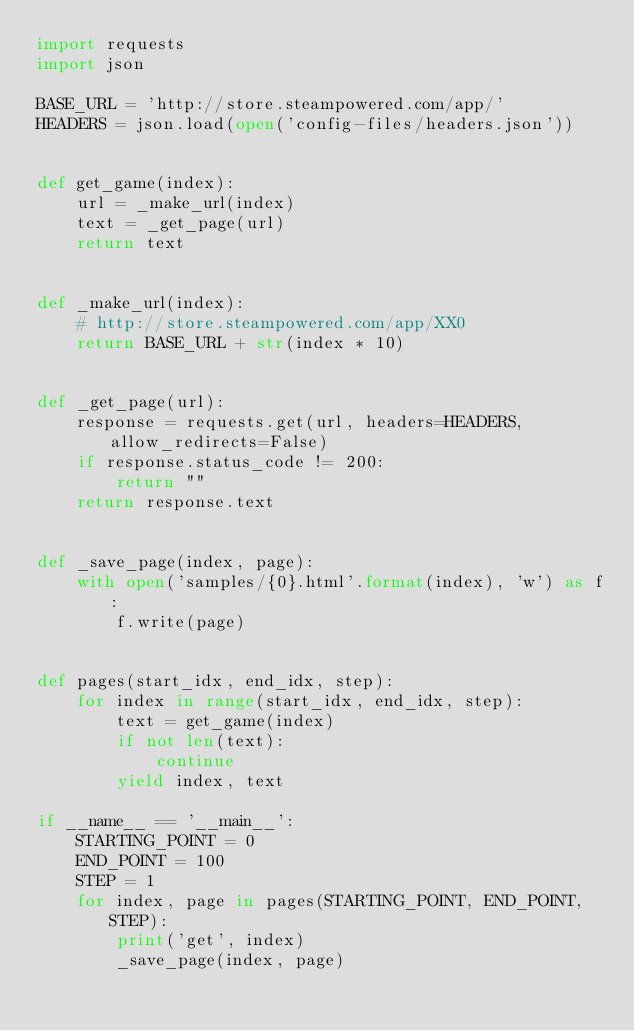Convert code to text. <code><loc_0><loc_0><loc_500><loc_500><_Python_>import requests
import json

BASE_URL = 'http://store.steampowered.com/app/'
HEADERS = json.load(open('config-files/headers.json'))


def get_game(index):
    url = _make_url(index)
    text = _get_page(url)
    return text


def _make_url(index):
    # http://store.steampowered.com/app/XX0
    return BASE_URL + str(index * 10)


def _get_page(url):
    response = requests.get(url, headers=HEADERS, allow_redirects=False)
    if response.status_code != 200:
        return ""
    return response.text


def _save_page(index, page):
    with open('samples/{0}.html'.format(index), 'w') as f:
        f.write(page)


def pages(start_idx, end_idx, step):
    for index in range(start_idx, end_idx, step):
        text = get_game(index)
        if not len(text):
            continue
        yield index, text

if __name__ == '__main__':
    STARTING_POINT = 0
    END_POINT = 100
    STEP = 1
    for index, page in pages(STARTING_POINT, END_POINT, STEP):
        print('get', index)
        _save_page(index, page)
</code> 